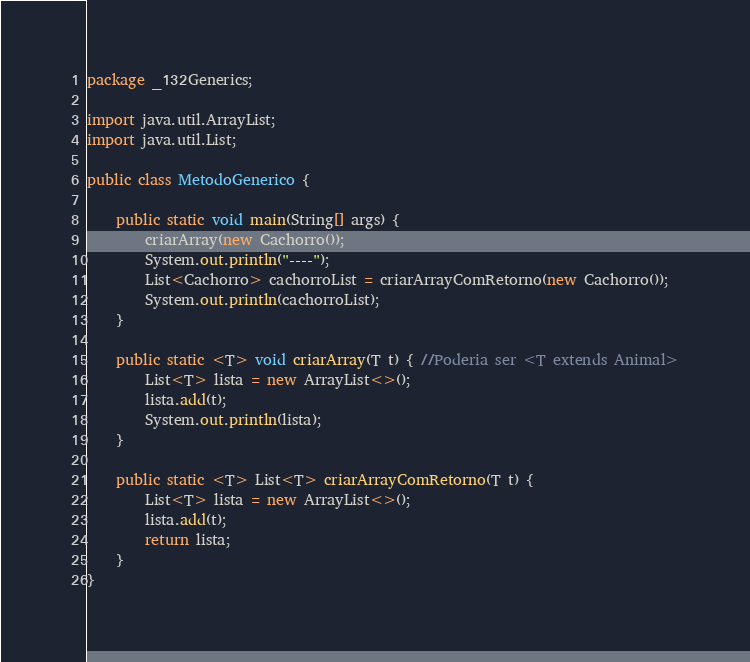Convert code to text. <code><loc_0><loc_0><loc_500><loc_500><_Java_>package _132Generics;

import java.util.ArrayList;
import java.util.List;

public class MetodoGenerico {

	public static void main(String[] args) {
		criarArray(new Cachorro());
		System.out.println("----");
		List<Cachorro> cachorroList = criarArrayComRetorno(new Cachorro());
		System.out.println(cachorroList);
	}

	public static <T> void criarArray(T t) { //Poderia ser <T extends Animal>
		List<T> lista = new ArrayList<>();
		lista.add(t);
		System.out.println(lista);
	}
	
	public static <T> List<T> criarArrayComRetorno(T t) {
		List<T> lista = new ArrayList<>();
		lista.add(t);
		return lista;
	}
}
</code> 